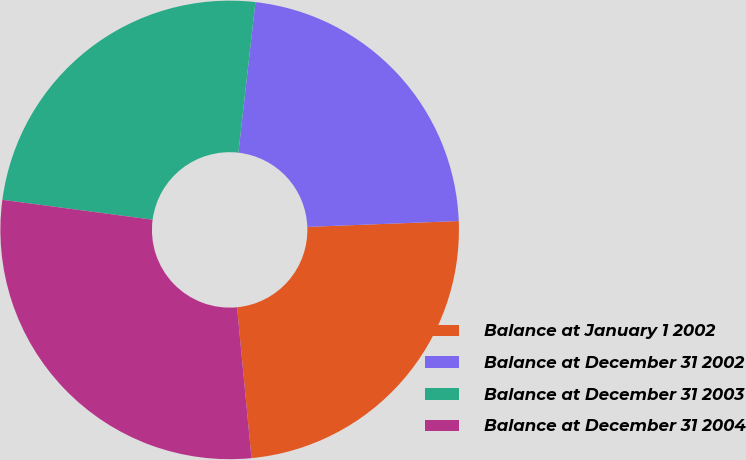Convert chart. <chart><loc_0><loc_0><loc_500><loc_500><pie_chart><fcel>Balance at January 1 2002<fcel>Balance at December 31 2002<fcel>Balance at December 31 2003<fcel>Balance at December 31 2004<nl><fcel>24.1%<fcel>22.59%<fcel>24.7%<fcel>28.61%<nl></chart> 